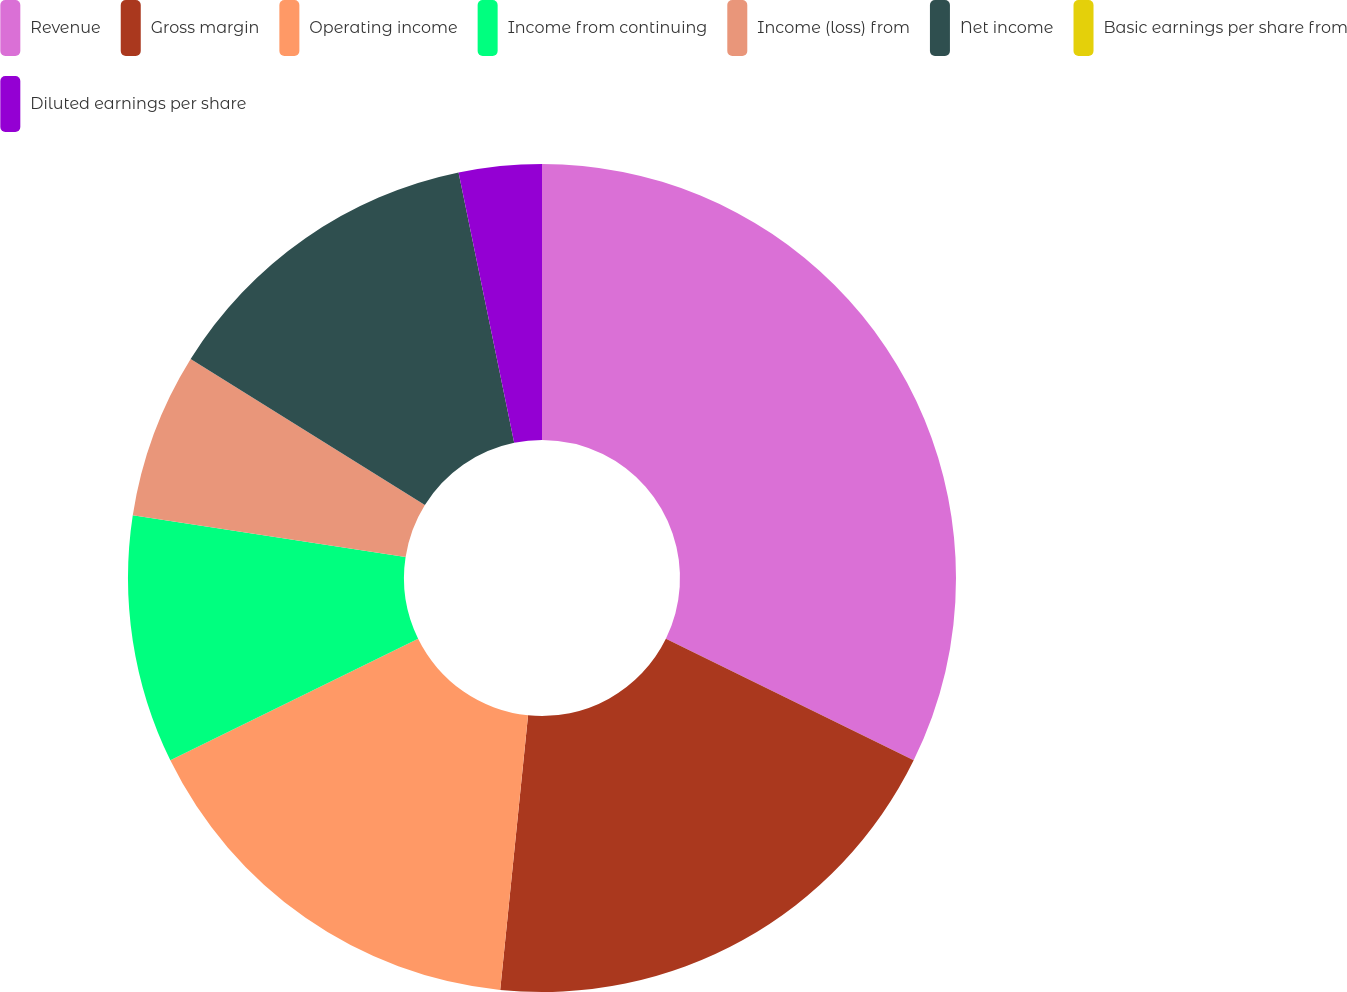Convert chart to OTSL. <chart><loc_0><loc_0><loc_500><loc_500><pie_chart><fcel>Revenue<fcel>Gross margin<fcel>Operating income<fcel>Income from continuing<fcel>Income (loss) from<fcel>Net income<fcel>Basic earnings per share from<fcel>Diluted earnings per share<nl><fcel>32.26%<fcel>19.35%<fcel>16.13%<fcel>9.68%<fcel>6.45%<fcel>12.9%<fcel>0.0%<fcel>3.23%<nl></chart> 